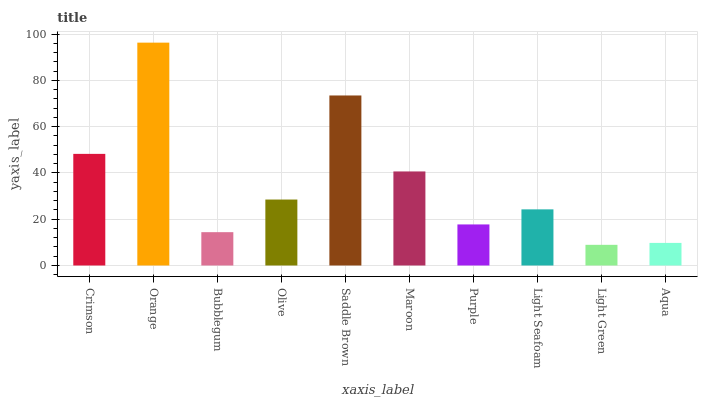Is Light Green the minimum?
Answer yes or no. Yes. Is Orange the maximum?
Answer yes or no. Yes. Is Bubblegum the minimum?
Answer yes or no. No. Is Bubblegum the maximum?
Answer yes or no. No. Is Orange greater than Bubblegum?
Answer yes or no. Yes. Is Bubblegum less than Orange?
Answer yes or no. Yes. Is Bubblegum greater than Orange?
Answer yes or no. No. Is Orange less than Bubblegum?
Answer yes or no. No. Is Olive the high median?
Answer yes or no. Yes. Is Light Seafoam the low median?
Answer yes or no. Yes. Is Light Seafoam the high median?
Answer yes or no. No. Is Crimson the low median?
Answer yes or no. No. 